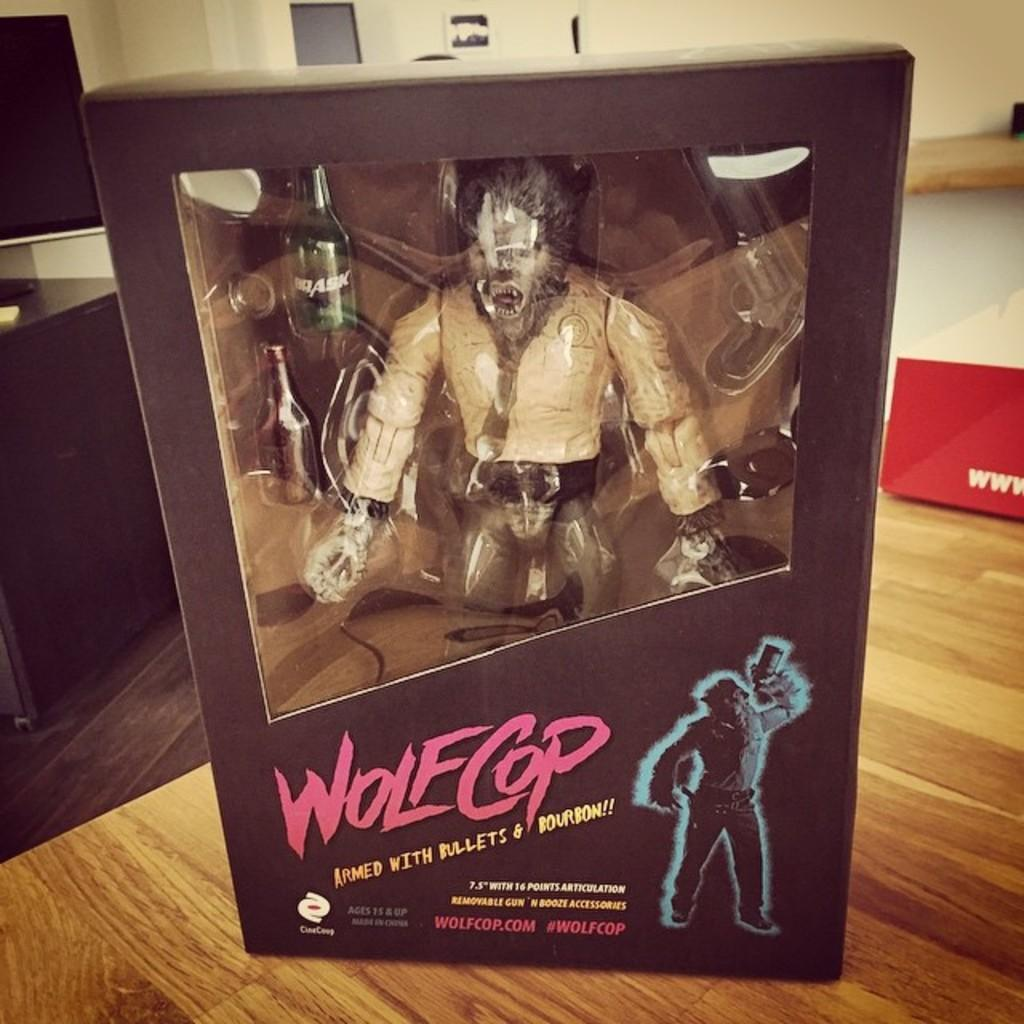<image>
Create a compact narrative representing the image presented. Boxed 7.5 inch action figure of WolfCop armed with bullets and bourbon!! 